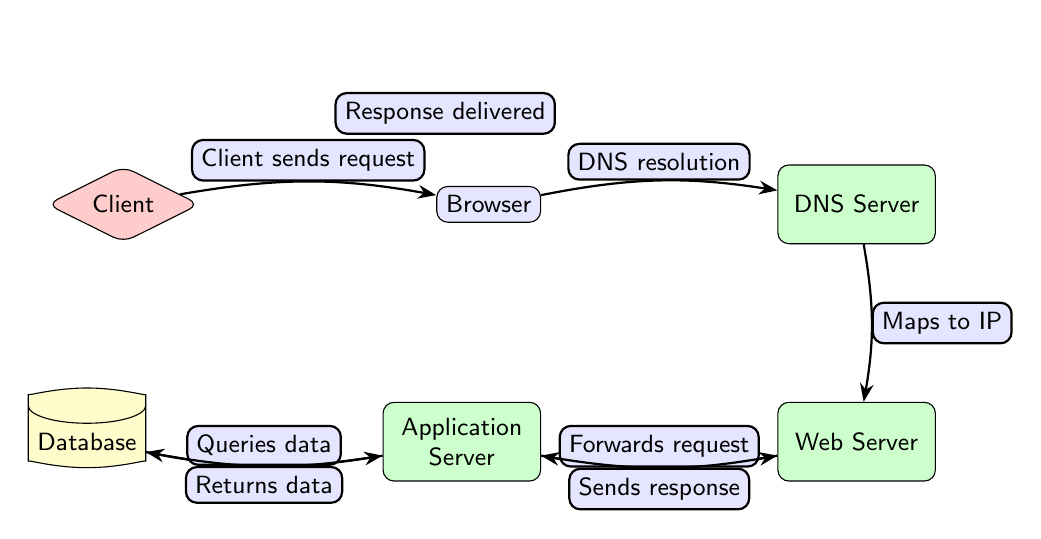What is the first step in the data flow? The diagram shows that the first step in the data flow starts with the Client sending a request to the Browser.
Answer: Client sends request How many servers are indicated in the diagram? The diagram shows three servers: DNS Server, Web Server, and Application Server.
Answer: Three What does the DNS Server do in the flow? The DNS Server resolves the domain name and maps it to an IP address, which is necessary for the Web Server to process the request.
Answer: Maps to IP What action does the Application Server take before responding? The Application Server queries the Database to retrieve the necessary data before it can send a response back to the Web Server.
Answer: Queries data What is returned from the Database to the Application Server? The Database returns the data that was requested by the Application Server to fulfill the original client request.
Answer: Returns data Which node delivers the final response to the Client? The Web Server is responsible for delivering the final response back to the Client after processing the request through the flow.
Answer: Response delivered What is the relationship between the Web Server and the Application Server? The Web Server forwards the request to the Application Server, indicating a flow of information between the two nodes in the process.
Answer: Forwards request What is the flow direction from the Database to the Application Server? The flow direction from the Database to the Application Server is illustrated as a return path of data, which is marked with a bend.
Answer: Bend right How does the Client know the server's IP address? The Client's request goes through the Browser to the DNS Server, which resolves the domain name to an IP address, ensuring proper routing of the request.
Answer: DNS resolution 